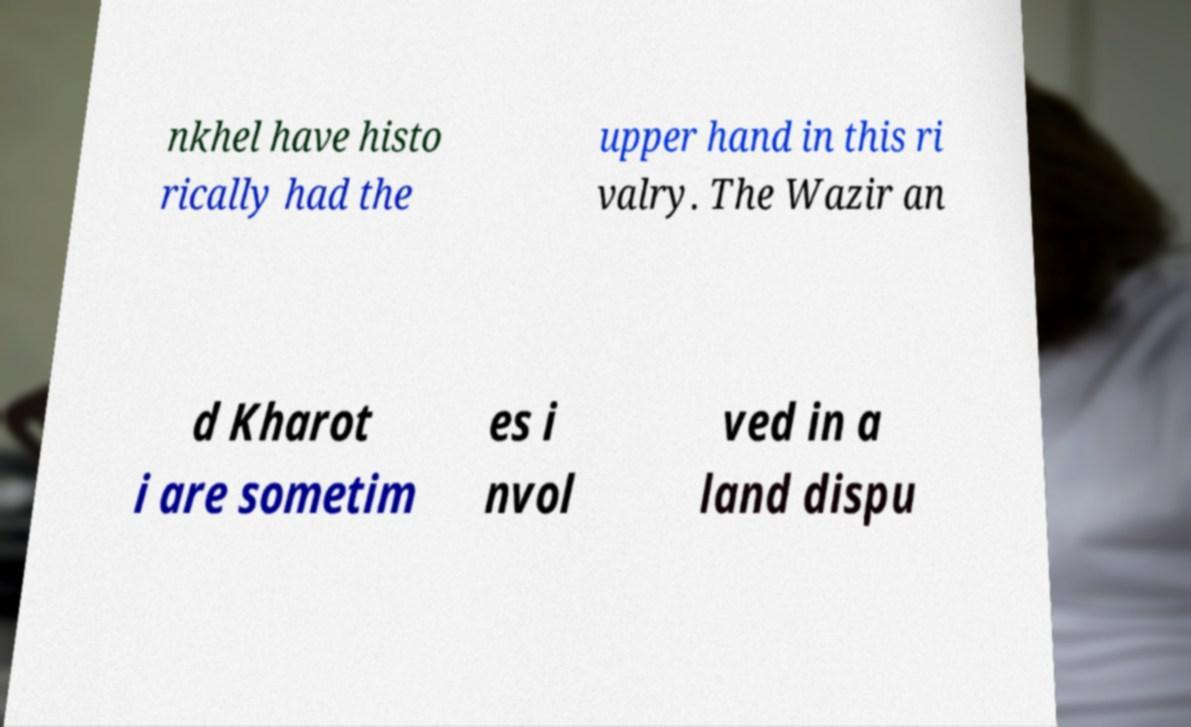What messages or text are displayed in this image? I need them in a readable, typed format. nkhel have histo rically had the upper hand in this ri valry. The Wazir an d Kharot i are sometim es i nvol ved in a land dispu 